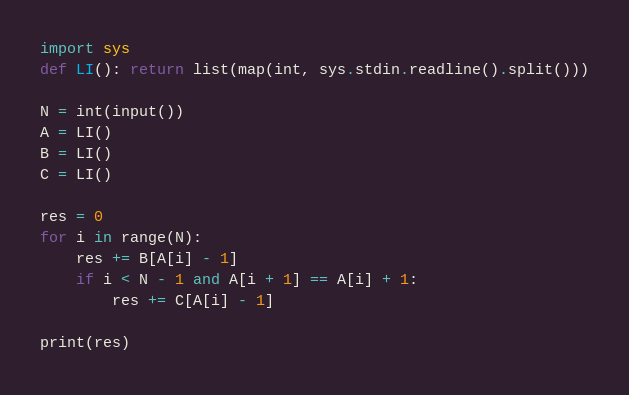<code> <loc_0><loc_0><loc_500><loc_500><_Python_>import sys
def LI(): return list(map(int, sys.stdin.readline().split()))

N = int(input())
A = LI()
B = LI()
C = LI()

res = 0
for i in range(N):
    res += B[A[i] - 1]
    if i < N - 1 and A[i + 1] == A[i] + 1:
        res += C[A[i] - 1]

print(res)</code> 